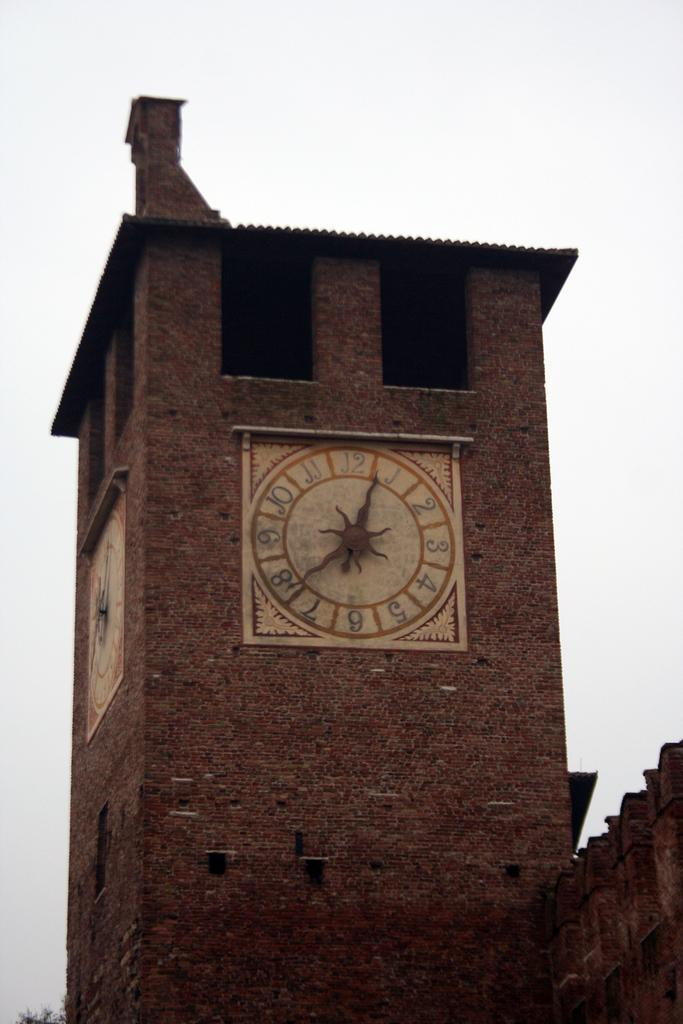<image>
Render a clear and concise summary of the photo. A clock on a tower is showing about 12:40. 